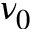Convert formula to latex. <formula><loc_0><loc_0><loc_500><loc_500>\nu _ { 0 }</formula> 